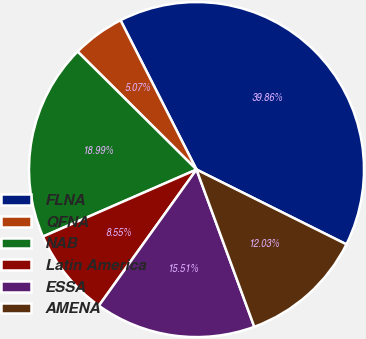Convert chart. <chart><loc_0><loc_0><loc_500><loc_500><pie_chart><fcel>FLNA<fcel>QFNA<fcel>NAB<fcel>Latin America<fcel>ESSA<fcel>AMENA<nl><fcel>39.86%<fcel>5.07%<fcel>18.99%<fcel>8.55%<fcel>15.51%<fcel>12.03%<nl></chart> 